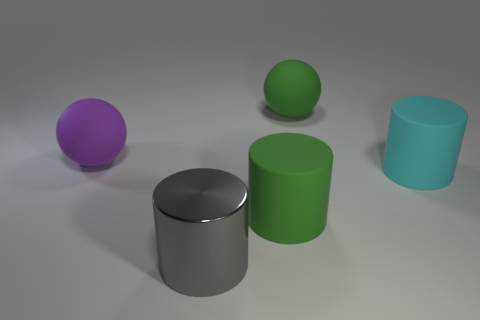Subtract all red cylinders. Subtract all red cubes. How many cylinders are left? 3 Add 2 big green balls. How many objects exist? 7 Subtract all cylinders. How many objects are left? 2 Add 2 large cyan rubber cylinders. How many large cyan rubber cylinders exist? 3 Subtract 0 purple cylinders. How many objects are left? 5 Subtract all large green matte things. Subtract all large gray cylinders. How many objects are left? 2 Add 3 gray objects. How many gray objects are left? 4 